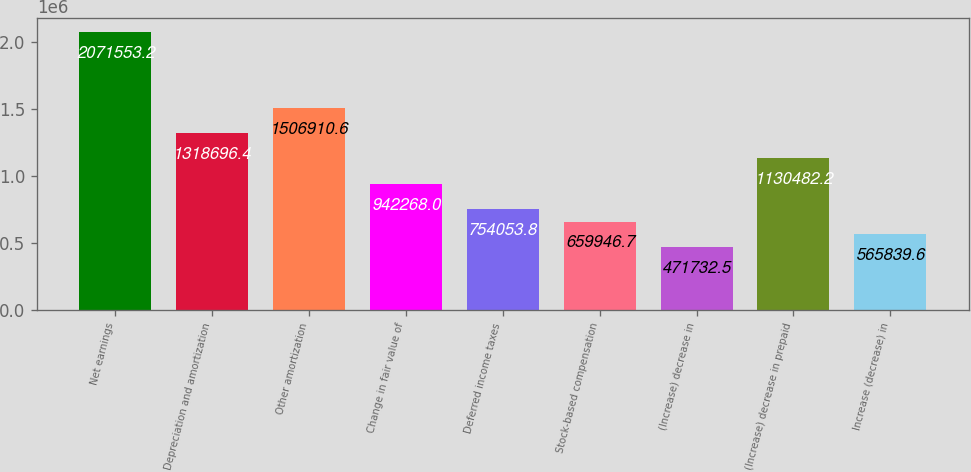<chart> <loc_0><loc_0><loc_500><loc_500><bar_chart><fcel>Net earnings<fcel>Depreciation and amortization<fcel>Other amortization<fcel>Change in fair value of<fcel>Deferred income taxes<fcel>Stock-based compensation<fcel>(Increase) decrease in<fcel>(Increase) decrease in prepaid<fcel>Increase (decrease) in<nl><fcel>2.07155e+06<fcel>1.3187e+06<fcel>1.50691e+06<fcel>942268<fcel>754054<fcel>659947<fcel>471732<fcel>1.13048e+06<fcel>565840<nl></chart> 